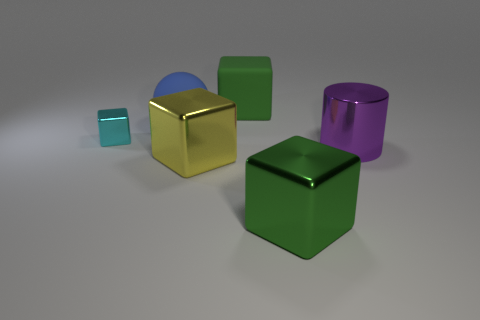How many objects are there in the image, and can you describe them? There are five objects in the image. Starting from the left, there's a small teal cube with a reflective surface. Next is a large gold cube that's also reflective. Behind the gold cube, there's a blue semi-cylinder with both shiny and matte finishes. To the right, there's a smaller matte green cube and finally, a reflective purple cylinder positioned at the back right. 